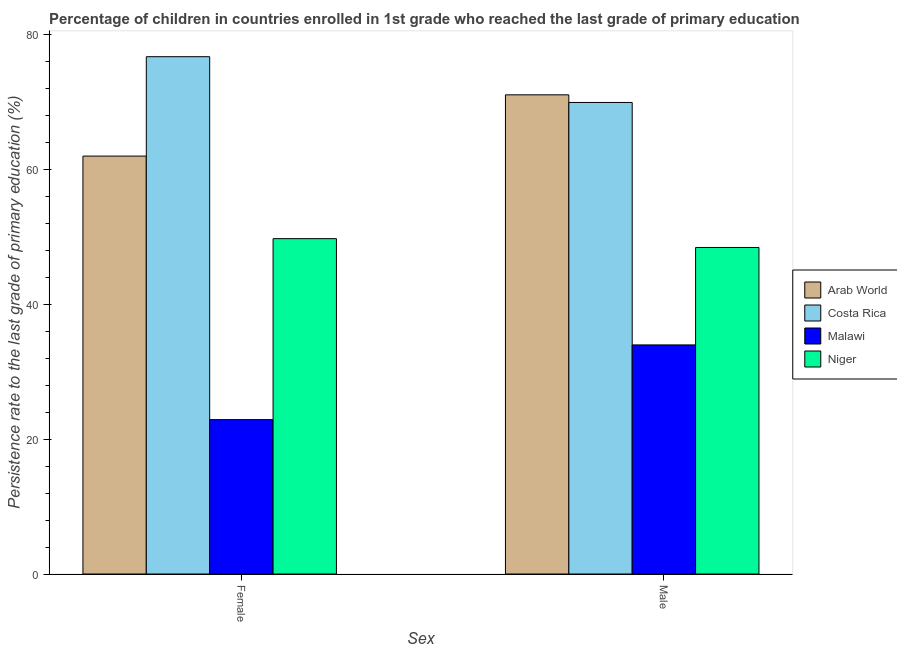How many different coloured bars are there?
Keep it short and to the point. 4. How many bars are there on the 1st tick from the left?
Give a very brief answer. 4. What is the persistence rate of female students in Arab World?
Your answer should be very brief. 61.94. Across all countries, what is the maximum persistence rate of male students?
Keep it short and to the point. 71.02. Across all countries, what is the minimum persistence rate of male students?
Give a very brief answer. 33.95. In which country was the persistence rate of female students maximum?
Give a very brief answer. Costa Rica. In which country was the persistence rate of female students minimum?
Offer a very short reply. Malawi. What is the total persistence rate of male students in the graph?
Keep it short and to the point. 223.25. What is the difference between the persistence rate of male students in Costa Rica and that in Arab World?
Ensure brevity in your answer.  -1.13. What is the difference between the persistence rate of female students in Malawi and the persistence rate of male students in Costa Rica?
Give a very brief answer. -47.01. What is the average persistence rate of male students per country?
Offer a very short reply. 55.81. What is the difference between the persistence rate of male students and persistence rate of female students in Costa Rica?
Your answer should be very brief. -6.78. What is the ratio of the persistence rate of male students in Costa Rica to that in Niger?
Provide a succinct answer. 1.44. In how many countries, is the persistence rate of male students greater than the average persistence rate of male students taken over all countries?
Offer a very short reply. 2. What does the 3rd bar from the left in Male represents?
Your response must be concise. Malawi. What does the 3rd bar from the right in Male represents?
Provide a succinct answer. Costa Rica. How many bars are there?
Offer a terse response. 8. Are all the bars in the graph horizontal?
Provide a succinct answer. No. Are the values on the major ticks of Y-axis written in scientific E-notation?
Offer a very short reply. No. Does the graph contain any zero values?
Make the answer very short. No. Does the graph contain grids?
Make the answer very short. No. How many legend labels are there?
Your response must be concise. 4. How are the legend labels stacked?
Make the answer very short. Vertical. What is the title of the graph?
Offer a very short reply. Percentage of children in countries enrolled in 1st grade who reached the last grade of primary education. What is the label or title of the X-axis?
Your response must be concise. Sex. What is the label or title of the Y-axis?
Provide a succinct answer. Persistence rate to the last grade of primary education (%). What is the Persistence rate to the last grade of primary education (%) in Arab World in Female?
Make the answer very short. 61.94. What is the Persistence rate to the last grade of primary education (%) in Costa Rica in Female?
Your answer should be compact. 76.67. What is the Persistence rate to the last grade of primary education (%) of Malawi in Female?
Ensure brevity in your answer.  22.88. What is the Persistence rate to the last grade of primary education (%) of Niger in Female?
Your answer should be compact. 49.7. What is the Persistence rate to the last grade of primary education (%) in Arab World in Male?
Offer a terse response. 71.02. What is the Persistence rate to the last grade of primary education (%) of Costa Rica in Male?
Make the answer very short. 69.89. What is the Persistence rate to the last grade of primary education (%) in Malawi in Male?
Make the answer very short. 33.95. What is the Persistence rate to the last grade of primary education (%) in Niger in Male?
Give a very brief answer. 48.39. Across all Sex, what is the maximum Persistence rate to the last grade of primary education (%) of Arab World?
Make the answer very short. 71.02. Across all Sex, what is the maximum Persistence rate to the last grade of primary education (%) of Costa Rica?
Your answer should be compact. 76.67. Across all Sex, what is the maximum Persistence rate to the last grade of primary education (%) in Malawi?
Your response must be concise. 33.95. Across all Sex, what is the maximum Persistence rate to the last grade of primary education (%) of Niger?
Offer a very short reply. 49.7. Across all Sex, what is the minimum Persistence rate to the last grade of primary education (%) in Arab World?
Your answer should be compact. 61.94. Across all Sex, what is the minimum Persistence rate to the last grade of primary education (%) of Costa Rica?
Provide a succinct answer. 69.89. Across all Sex, what is the minimum Persistence rate to the last grade of primary education (%) in Malawi?
Offer a terse response. 22.88. Across all Sex, what is the minimum Persistence rate to the last grade of primary education (%) in Niger?
Your response must be concise. 48.39. What is the total Persistence rate to the last grade of primary education (%) of Arab World in the graph?
Your answer should be very brief. 132.96. What is the total Persistence rate to the last grade of primary education (%) in Costa Rica in the graph?
Your answer should be compact. 146.56. What is the total Persistence rate to the last grade of primary education (%) in Malawi in the graph?
Your answer should be very brief. 56.83. What is the total Persistence rate to the last grade of primary education (%) of Niger in the graph?
Offer a terse response. 98.1. What is the difference between the Persistence rate to the last grade of primary education (%) in Arab World in Female and that in Male?
Provide a succinct answer. -9.08. What is the difference between the Persistence rate to the last grade of primary education (%) of Costa Rica in Female and that in Male?
Offer a very short reply. 6.78. What is the difference between the Persistence rate to the last grade of primary education (%) of Malawi in Female and that in Male?
Keep it short and to the point. -11.07. What is the difference between the Persistence rate to the last grade of primary education (%) of Niger in Female and that in Male?
Offer a very short reply. 1.31. What is the difference between the Persistence rate to the last grade of primary education (%) in Arab World in Female and the Persistence rate to the last grade of primary education (%) in Costa Rica in Male?
Ensure brevity in your answer.  -7.95. What is the difference between the Persistence rate to the last grade of primary education (%) in Arab World in Female and the Persistence rate to the last grade of primary education (%) in Malawi in Male?
Your response must be concise. 27.99. What is the difference between the Persistence rate to the last grade of primary education (%) in Arab World in Female and the Persistence rate to the last grade of primary education (%) in Niger in Male?
Offer a very short reply. 13.54. What is the difference between the Persistence rate to the last grade of primary education (%) in Costa Rica in Female and the Persistence rate to the last grade of primary education (%) in Malawi in Male?
Provide a succinct answer. 42.72. What is the difference between the Persistence rate to the last grade of primary education (%) in Costa Rica in Female and the Persistence rate to the last grade of primary education (%) in Niger in Male?
Your response must be concise. 28.28. What is the difference between the Persistence rate to the last grade of primary education (%) of Malawi in Female and the Persistence rate to the last grade of primary education (%) of Niger in Male?
Provide a succinct answer. -25.51. What is the average Persistence rate to the last grade of primary education (%) of Arab World per Sex?
Keep it short and to the point. 66.48. What is the average Persistence rate to the last grade of primary education (%) in Costa Rica per Sex?
Provide a short and direct response. 73.28. What is the average Persistence rate to the last grade of primary education (%) in Malawi per Sex?
Your response must be concise. 28.42. What is the average Persistence rate to the last grade of primary education (%) of Niger per Sex?
Make the answer very short. 49.05. What is the difference between the Persistence rate to the last grade of primary education (%) of Arab World and Persistence rate to the last grade of primary education (%) of Costa Rica in Female?
Make the answer very short. -14.73. What is the difference between the Persistence rate to the last grade of primary education (%) of Arab World and Persistence rate to the last grade of primary education (%) of Malawi in Female?
Your answer should be compact. 39.06. What is the difference between the Persistence rate to the last grade of primary education (%) in Arab World and Persistence rate to the last grade of primary education (%) in Niger in Female?
Provide a short and direct response. 12.24. What is the difference between the Persistence rate to the last grade of primary education (%) of Costa Rica and Persistence rate to the last grade of primary education (%) of Malawi in Female?
Make the answer very short. 53.79. What is the difference between the Persistence rate to the last grade of primary education (%) of Costa Rica and Persistence rate to the last grade of primary education (%) of Niger in Female?
Give a very brief answer. 26.97. What is the difference between the Persistence rate to the last grade of primary education (%) in Malawi and Persistence rate to the last grade of primary education (%) in Niger in Female?
Your response must be concise. -26.82. What is the difference between the Persistence rate to the last grade of primary education (%) of Arab World and Persistence rate to the last grade of primary education (%) of Costa Rica in Male?
Provide a short and direct response. 1.13. What is the difference between the Persistence rate to the last grade of primary education (%) of Arab World and Persistence rate to the last grade of primary education (%) of Malawi in Male?
Give a very brief answer. 37.06. What is the difference between the Persistence rate to the last grade of primary education (%) of Arab World and Persistence rate to the last grade of primary education (%) of Niger in Male?
Your answer should be very brief. 22.62. What is the difference between the Persistence rate to the last grade of primary education (%) of Costa Rica and Persistence rate to the last grade of primary education (%) of Malawi in Male?
Ensure brevity in your answer.  35.93. What is the difference between the Persistence rate to the last grade of primary education (%) of Costa Rica and Persistence rate to the last grade of primary education (%) of Niger in Male?
Make the answer very short. 21.49. What is the difference between the Persistence rate to the last grade of primary education (%) in Malawi and Persistence rate to the last grade of primary education (%) in Niger in Male?
Your answer should be compact. -14.44. What is the ratio of the Persistence rate to the last grade of primary education (%) in Arab World in Female to that in Male?
Your response must be concise. 0.87. What is the ratio of the Persistence rate to the last grade of primary education (%) in Costa Rica in Female to that in Male?
Ensure brevity in your answer.  1.1. What is the ratio of the Persistence rate to the last grade of primary education (%) of Malawi in Female to that in Male?
Make the answer very short. 0.67. What is the difference between the highest and the second highest Persistence rate to the last grade of primary education (%) of Arab World?
Make the answer very short. 9.08. What is the difference between the highest and the second highest Persistence rate to the last grade of primary education (%) of Costa Rica?
Keep it short and to the point. 6.78. What is the difference between the highest and the second highest Persistence rate to the last grade of primary education (%) of Malawi?
Your response must be concise. 11.07. What is the difference between the highest and the second highest Persistence rate to the last grade of primary education (%) in Niger?
Give a very brief answer. 1.31. What is the difference between the highest and the lowest Persistence rate to the last grade of primary education (%) of Arab World?
Your response must be concise. 9.08. What is the difference between the highest and the lowest Persistence rate to the last grade of primary education (%) in Costa Rica?
Ensure brevity in your answer.  6.78. What is the difference between the highest and the lowest Persistence rate to the last grade of primary education (%) of Malawi?
Offer a terse response. 11.07. What is the difference between the highest and the lowest Persistence rate to the last grade of primary education (%) of Niger?
Keep it short and to the point. 1.31. 